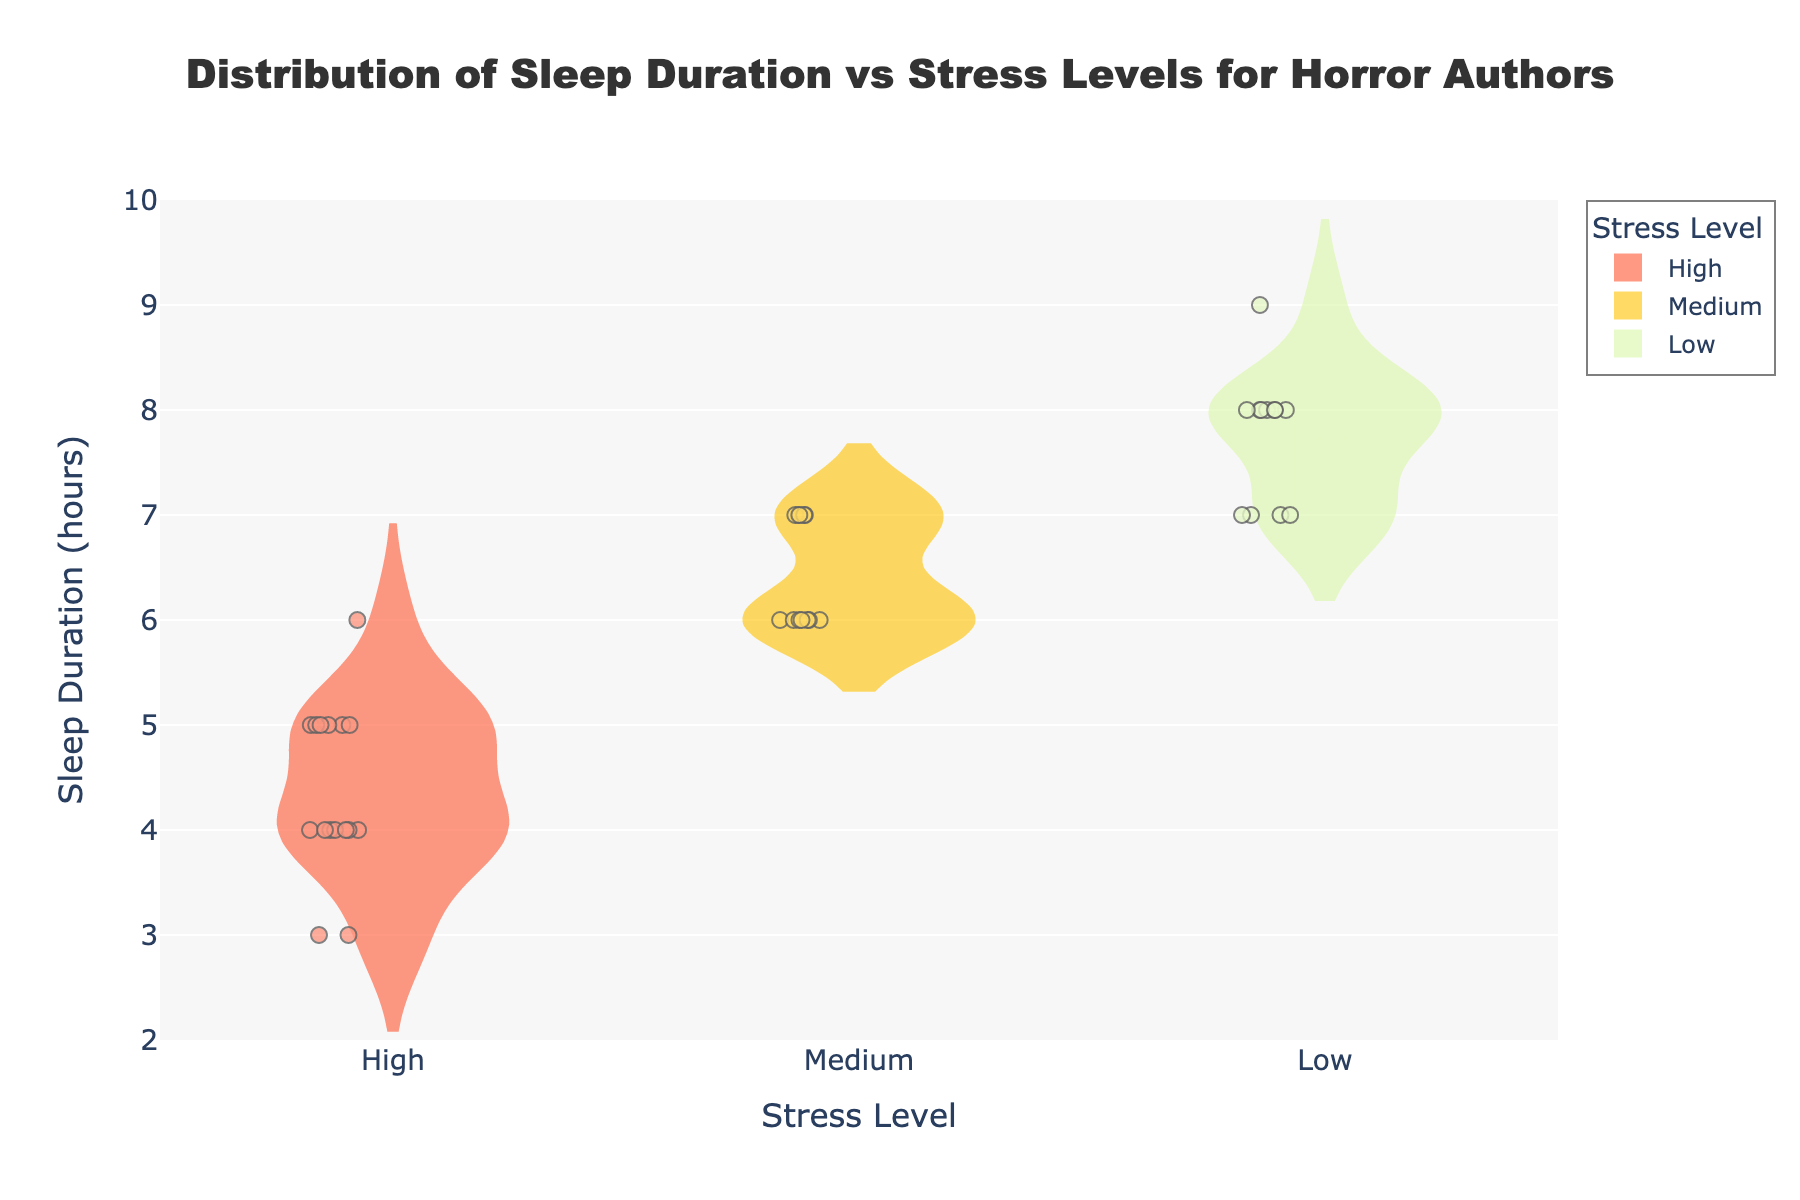what is the title of the figure? The title is provided at the top of the figure, centered and bold. It reads "Distribution of Sleep Duration vs Stress Levels for Horror Authors."
Answer: Distribution of Sleep Duration vs Stress Levels for Horror Authors Which stress level has the highest mean sleep duration? In the figure, each violin plot shows a horizontal line representing the mean. The mean line for the "Low" stress level is higher compared to "Medium" and "High."
Answer: Low What is the range of sleep duration for authors with high stress levels? The edge of each violin plot represents the range. For "High" stress, the range of sleep duration is from 3 to 6 hours.
Answer: 3 to 6 hours How many authors are there with low stress levels? Each point in the violin plot represents a data point for sleep duration. There are 3 authors (Stephen King, Anne Rice, Clive Barker, Dean Koontz) with 3 data points each, so a total of 12.
Answer: 12 Which author has the lowest sleep duration recorded and what is it? By reviewing the individual data points, Anne Rice shows sleep durations of 3 hours under high stress levels, which are the lowest recorded durations among all authors.
Answer: Anne Rice, 3 hours Compare the median sleep duration for Medium and High stress levels for Clive Barker. The box plot within the violins represents the median. Clive Barker's medium stress median is around 6 and high stress median is around 4.
Answer: 6 (Medium), 4 (High) Which stress level shows the widest distribution in sleep duration? The width of the violin plot represents the distribution. The "Low" stress level violin appears widest, indicating a broader distribution.
Answer: Low How do sleep patterns vary for Stephen King across different stress levels? Stephen King has sleep durations recorded at three different stress levels: Low (7-8 hours), Medium (6-7 hours), and High (4-6 hours), showing decreasing sleep duration with higher stress.
Answer: Decreases with higher stress Does the sleep duration for Dean Koontz under low stress vary much? The violin plot for low stress shows a narrow distribution around 7 to 8 hours for Dean Koontz, indicating little variation.
Answer: No, it does not vary much What’s the interquartile range (IQR) for sleep duration under medium stress levels? The edges of the box in the box plot indicate the 25th and 75th percentiles. For medium stress, the IQR is 6 to 7 hours.
Answer: 6 to 7 hours 